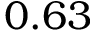Convert formula to latex. <formula><loc_0><loc_0><loc_500><loc_500>0 . 6 3</formula> 